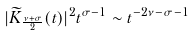<formula> <loc_0><loc_0><loc_500><loc_500>| \widetilde { K } _ { \frac { \nu + \sigma } { 2 } } ( t ) | ^ { 2 } t ^ { \sigma - 1 } \sim t ^ { - 2 \nu - \sigma - 1 }</formula> 